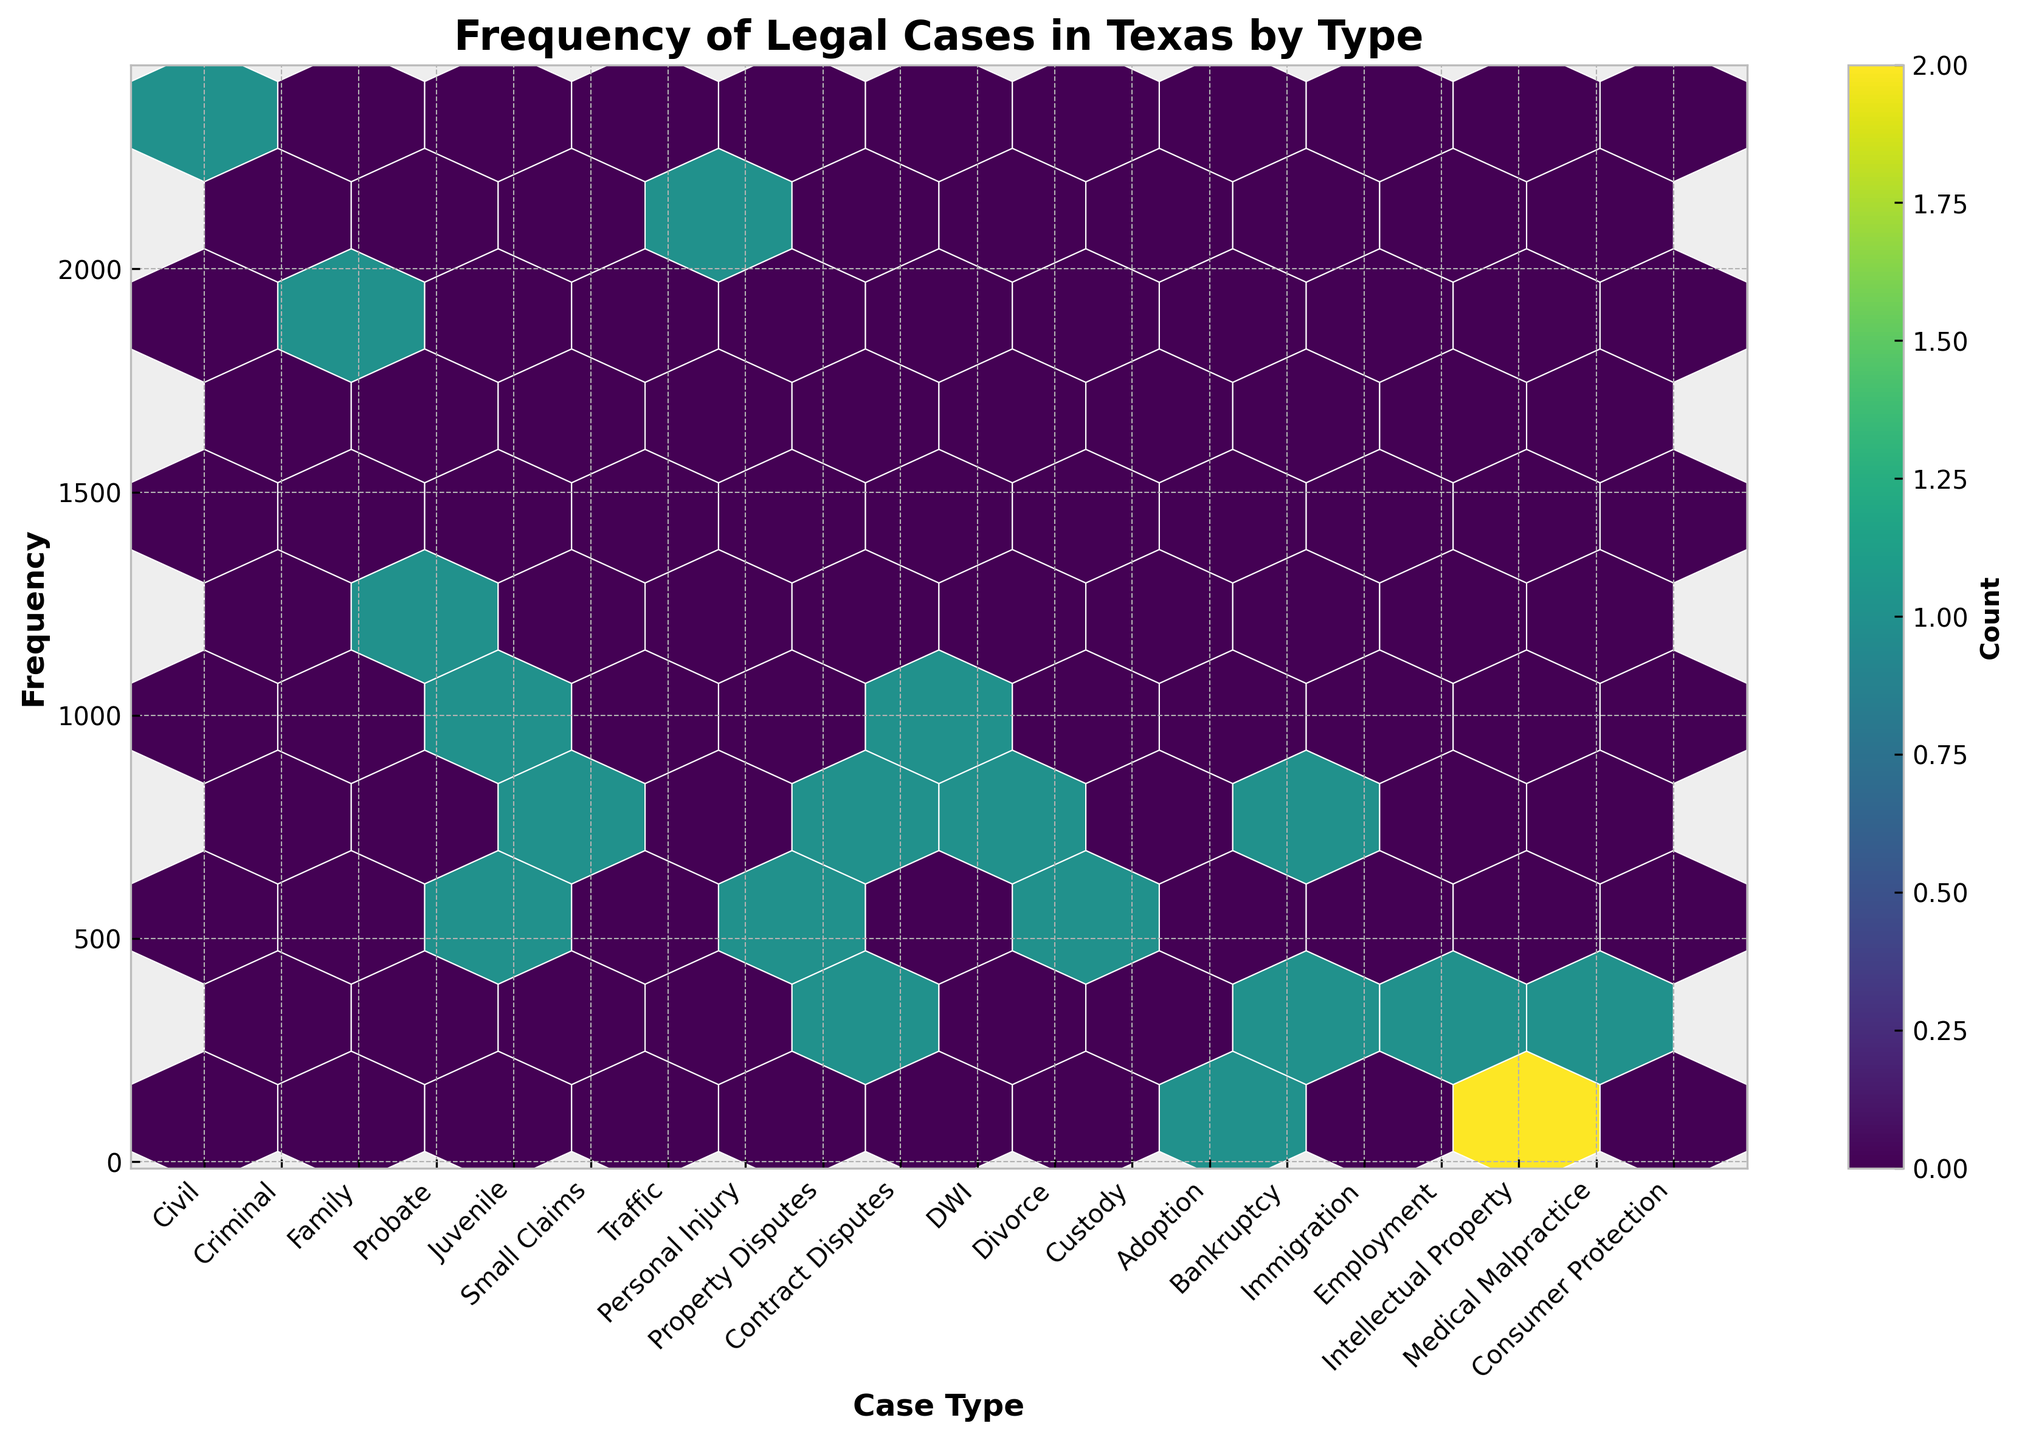What is the title of the plot? The title of the plot is usually displayed at the top center of the figure. According to the settings in the code, it should directly state the content being displayed.
Answer: Frequency of Legal Cases in Texas by Type Which case type has the highest frequency? By looking at the distribution and the hexbin densities, you can identify the case type with the highest value on the y-axis.
Answer: Civil (Harris County, 2345) How many case types are included in the plot? The number of unique ticks on the x-axis corresponds to the different case types. You can count these ticks to get the answer.
Answer: 19 Which case type appears to have the lowest frequency? By examining the hexbin plot and identifying the case with the lowest value on the y-axis, you can determine which case type has the lowest frequency.
Answer: Medical Malpractice (Smith County, 98) Is there a color gradient used in the plot, and what does it represent? Yes, the color gradient is indicated by the colormap used in the hexbin plot. The legend (color bar) typically shows the range of colors corresponding to the frequency count of cases.
Answer: Yes, it represents the count of cases How does the frequency of Divorce cases compare to DWI cases? Compare the y-axis values for "Divorce" (Montgomery County, 876) and "DWI" (Hidalgo County, 1098) to see which is higher.
Answer: DWI cases are more frequent What is the average frequency of Civil and Criminal cases? To calculate the average frequency, sum the frequencies of Civil (2345) and Criminal (1876) cases, then divide by 2. (2345 + 1876) / 2 = 2110.5
Answer: 2110.5 Which case type has a frequency closest to 500? Identify the hexbin closest to the y-axis value 500.
Answer: Custody (543) What's the range of frequencies displayed in the plot? The range is calculated as the difference between the highest and lowest frequency values. Highest is Civil (2345), lowest is Medical Malpractice (98). Range = 2345 - 98 = 2247
Answer: 2247 Which counties have the highest case frequency for Personal Injury and Property Disputes respectively? Identify the colors for Personal Injury and Property Disputes on the x-axis and find their corresponding y-values. Personal Injury is Fort Bend (543), Property Disputes is Denton (678).
Answer: Fort Bend (Personal Injury) and Denton (Property Disputes) 